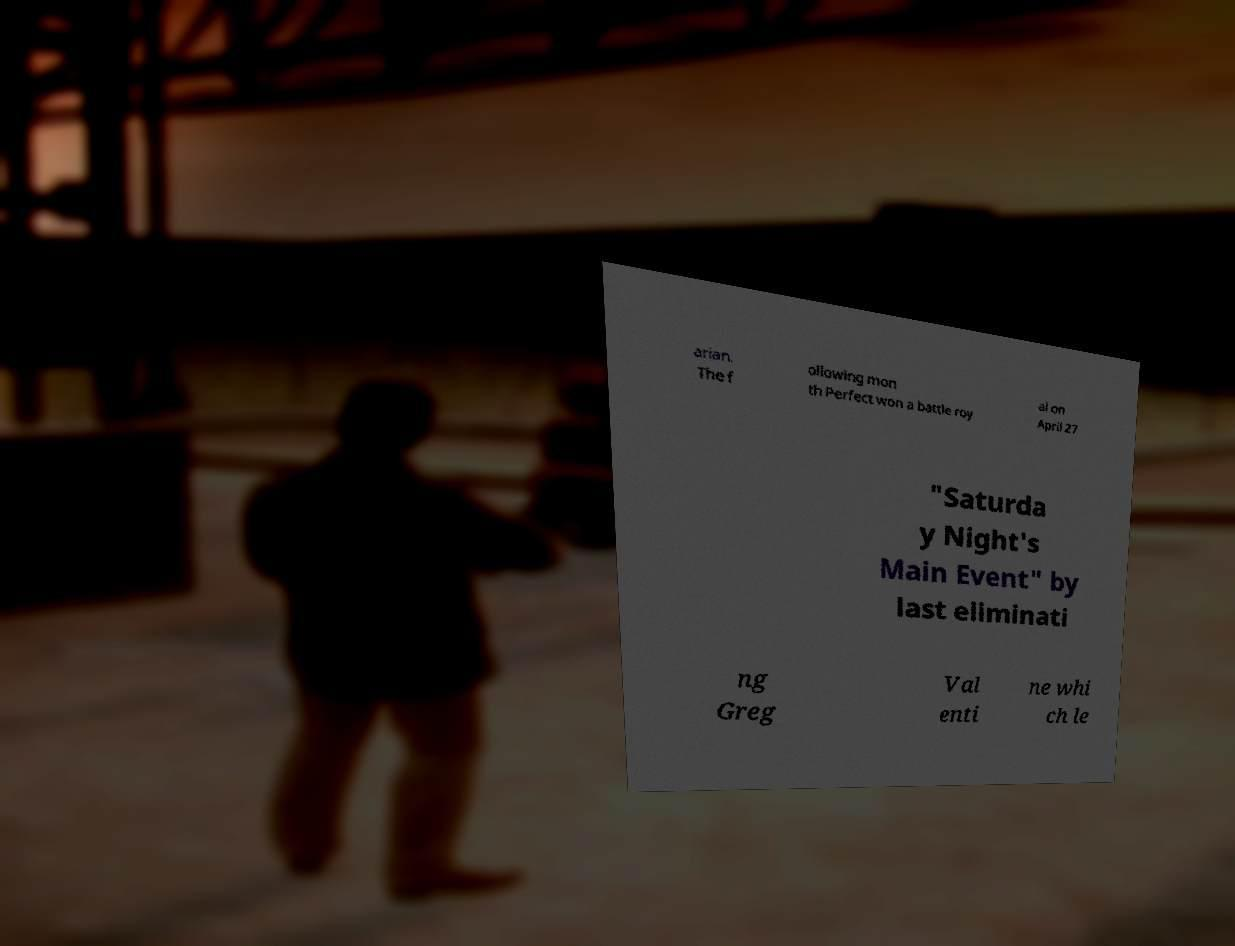Can you read and provide the text displayed in the image?This photo seems to have some interesting text. Can you extract and type it out for me? arian. The f ollowing mon th Perfect won a battle roy al on April 27 "Saturda y Night's Main Event" by last eliminati ng Greg Val enti ne whi ch le 